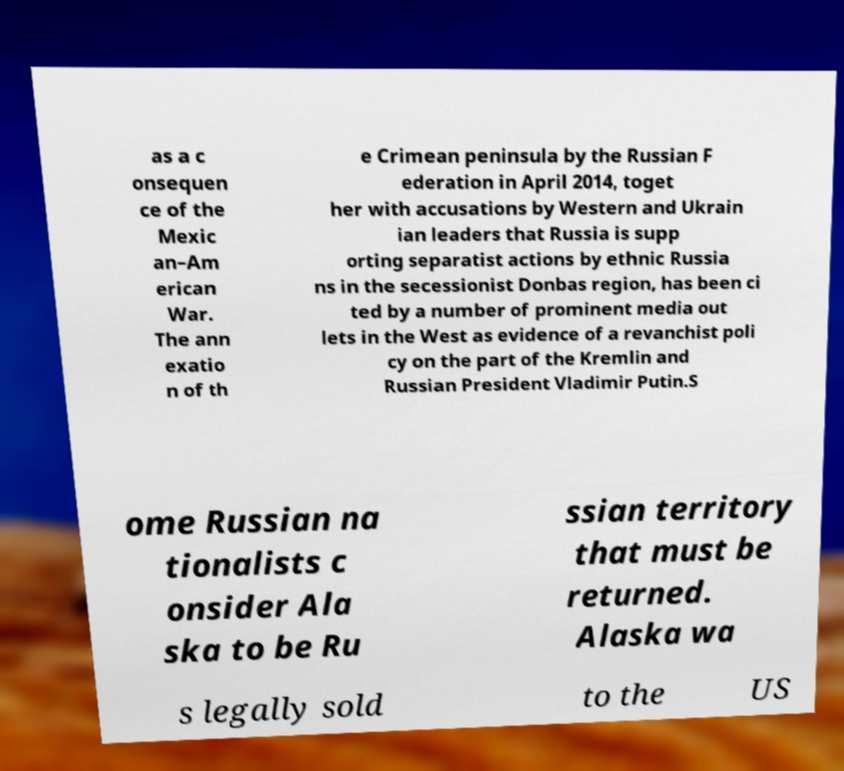For documentation purposes, I need the text within this image transcribed. Could you provide that? as a c onsequen ce of the Mexic an–Am erican War. The ann exatio n of th e Crimean peninsula by the Russian F ederation in April 2014, toget her with accusations by Western and Ukrain ian leaders that Russia is supp orting separatist actions by ethnic Russia ns in the secessionist Donbas region, has been ci ted by a number of prominent media out lets in the West as evidence of a revanchist poli cy on the part of the Kremlin and Russian President Vladimir Putin.S ome Russian na tionalists c onsider Ala ska to be Ru ssian territory that must be returned. Alaska wa s legally sold to the US 